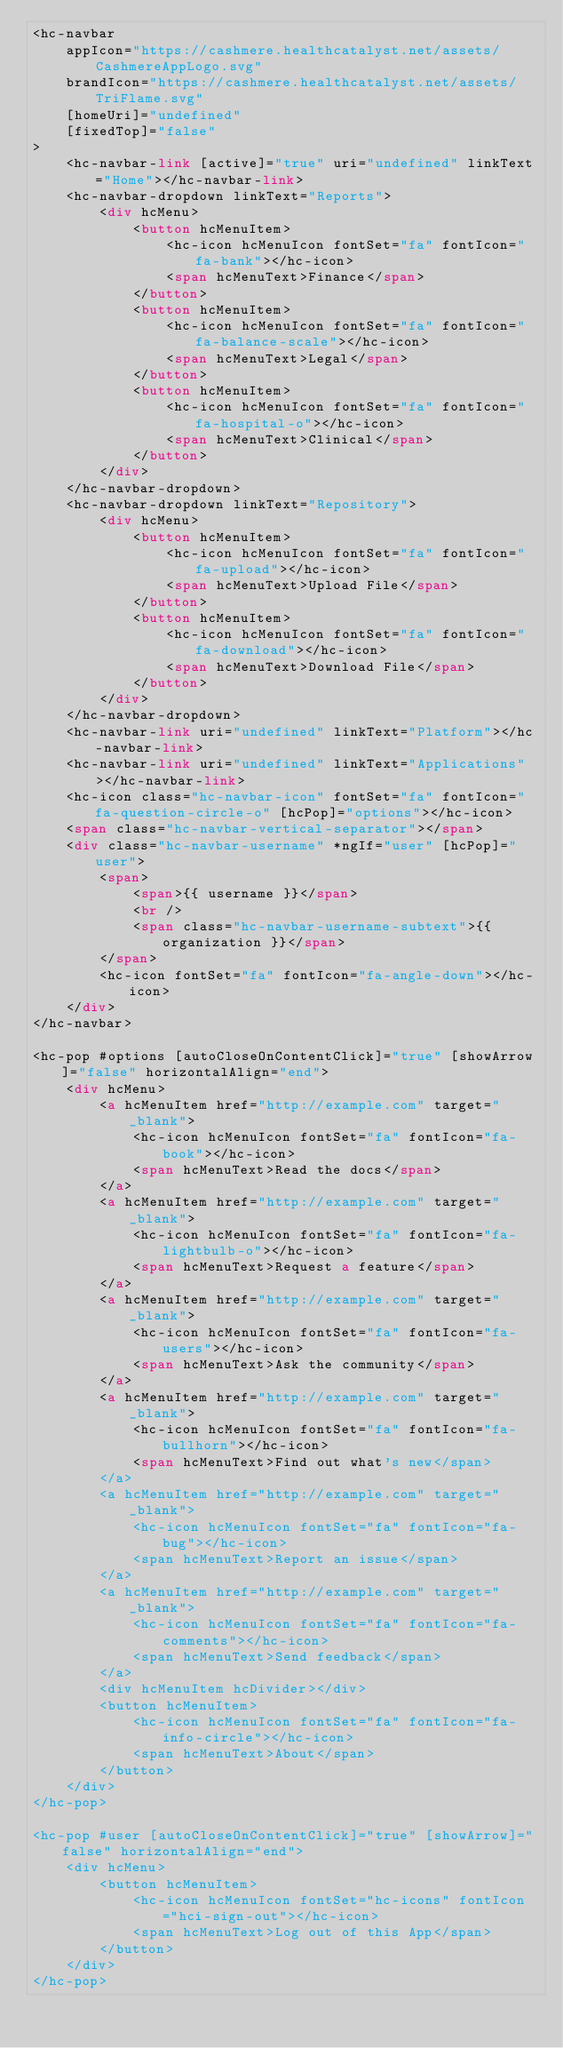Convert code to text. <code><loc_0><loc_0><loc_500><loc_500><_HTML_><hc-navbar
    appIcon="https://cashmere.healthcatalyst.net/assets/CashmereAppLogo.svg"
    brandIcon="https://cashmere.healthcatalyst.net/assets/TriFlame.svg"
    [homeUri]="undefined"
    [fixedTop]="false"
>
    <hc-navbar-link [active]="true" uri="undefined" linkText="Home"></hc-navbar-link>
    <hc-navbar-dropdown linkText="Reports">
        <div hcMenu>
            <button hcMenuItem>
                <hc-icon hcMenuIcon fontSet="fa" fontIcon="fa-bank"></hc-icon>
                <span hcMenuText>Finance</span>
            </button>
            <button hcMenuItem>
                <hc-icon hcMenuIcon fontSet="fa" fontIcon="fa-balance-scale"></hc-icon>
                <span hcMenuText>Legal</span>
            </button>
            <button hcMenuItem>
                <hc-icon hcMenuIcon fontSet="fa" fontIcon="fa-hospital-o"></hc-icon>
                <span hcMenuText>Clinical</span>
            </button>
        </div>
    </hc-navbar-dropdown>
    <hc-navbar-dropdown linkText="Repository">
        <div hcMenu>
            <button hcMenuItem>
                <hc-icon hcMenuIcon fontSet="fa" fontIcon="fa-upload"></hc-icon>
                <span hcMenuText>Upload File</span>
            </button>
            <button hcMenuItem>
                <hc-icon hcMenuIcon fontSet="fa" fontIcon="fa-download"></hc-icon>
                <span hcMenuText>Download File</span>
            </button>
        </div>
    </hc-navbar-dropdown>
    <hc-navbar-link uri="undefined" linkText="Platform"></hc-navbar-link>
    <hc-navbar-link uri="undefined" linkText="Applications"></hc-navbar-link>
    <hc-icon class="hc-navbar-icon" fontSet="fa" fontIcon="fa-question-circle-o" [hcPop]="options"></hc-icon>
    <span class="hc-navbar-vertical-separator"></span>
    <div class="hc-navbar-username" *ngIf="user" [hcPop]="user">
        <span>
            <span>{{ username }}</span>
            <br />
            <span class="hc-navbar-username-subtext">{{ organization }}</span>
        </span>
        <hc-icon fontSet="fa" fontIcon="fa-angle-down"></hc-icon>
    </div>
</hc-navbar>

<hc-pop #options [autoCloseOnContentClick]="true" [showArrow]="false" horizontalAlign="end">
    <div hcMenu>
        <a hcMenuItem href="http://example.com" target="_blank">
            <hc-icon hcMenuIcon fontSet="fa" fontIcon="fa-book"></hc-icon>
            <span hcMenuText>Read the docs</span>
        </a>
        <a hcMenuItem href="http://example.com" target="_blank">
            <hc-icon hcMenuIcon fontSet="fa" fontIcon="fa-lightbulb-o"></hc-icon>
            <span hcMenuText>Request a feature</span>
        </a>
        <a hcMenuItem href="http://example.com" target="_blank">
            <hc-icon hcMenuIcon fontSet="fa" fontIcon="fa-users"></hc-icon>
            <span hcMenuText>Ask the community</span>
        </a>
        <a hcMenuItem href="http://example.com" target="_blank">
            <hc-icon hcMenuIcon fontSet="fa" fontIcon="fa-bullhorn"></hc-icon>
            <span hcMenuText>Find out what's new</span>
        </a>
        <a hcMenuItem href="http://example.com" target="_blank">
            <hc-icon hcMenuIcon fontSet="fa" fontIcon="fa-bug"></hc-icon>
            <span hcMenuText>Report an issue</span>
        </a>
        <a hcMenuItem href="http://example.com" target="_blank">
            <hc-icon hcMenuIcon fontSet="fa" fontIcon="fa-comments"></hc-icon>
            <span hcMenuText>Send feedback</span>
        </a>
        <div hcMenuItem hcDivider></div>
        <button hcMenuItem>
            <hc-icon hcMenuIcon fontSet="fa" fontIcon="fa-info-circle"></hc-icon>
            <span hcMenuText>About</span>
        </button>
    </div>
</hc-pop>

<hc-pop #user [autoCloseOnContentClick]="true" [showArrow]="false" horizontalAlign="end">
    <div hcMenu>
        <button hcMenuItem>
            <hc-icon hcMenuIcon fontSet="hc-icons" fontIcon="hci-sign-out"></hc-icon>
            <span hcMenuText>Log out of this App</span>
        </button>
    </div>
</hc-pop>
</code> 